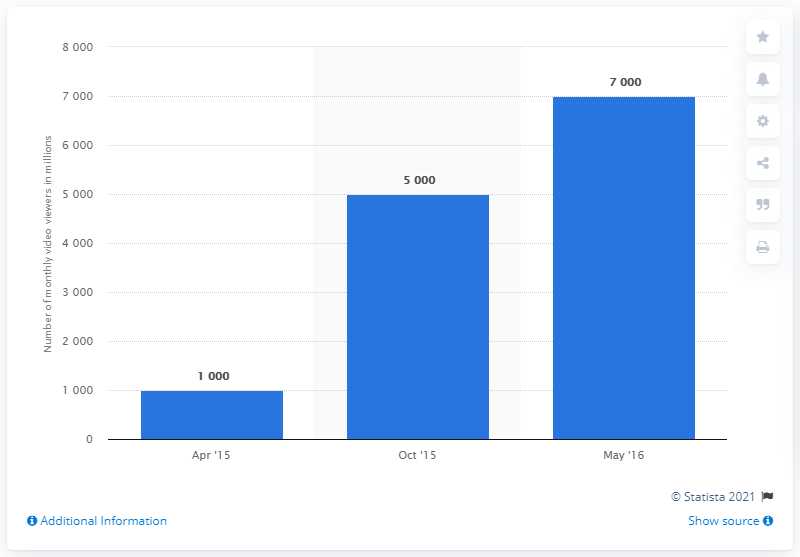Specify some key components in this picture. Approximately 7,000 people watch BuzzFeed videos each month. 